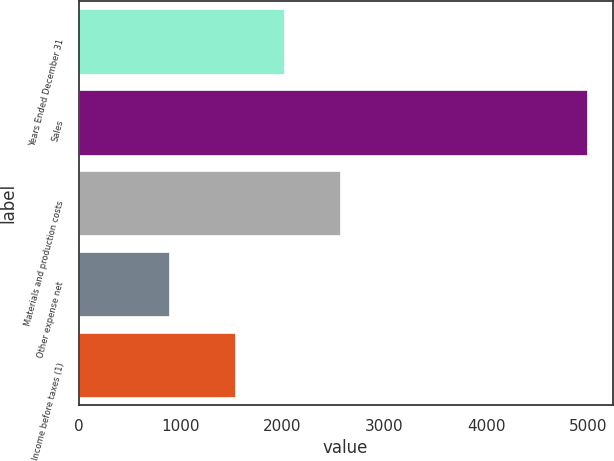<chart> <loc_0><loc_0><loc_500><loc_500><bar_chart><fcel>Years Ended December 31<fcel>Sales<fcel>Materials and production costs<fcel>Other expense net<fcel>Income before taxes (1)<nl><fcel>2010<fcel>4991<fcel>2568<fcel>886<fcel>1537<nl></chart> 